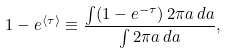<formula> <loc_0><loc_0><loc_500><loc_500>1 - e ^ { \langle \tau \rangle } \equiv \frac { \int ( 1 - e ^ { - \tau } ) \, 2 \pi a \, d a } { \int 2 \pi a \, d a } ,</formula> 